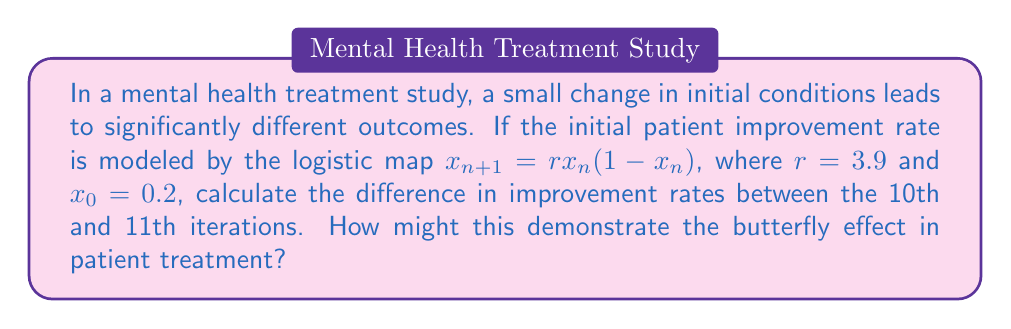Show me your answer to this math problem. To solve this problem, we need to iterate the logistic map for 11 steps and compare the 10th and 11th iterations. Let's break it down:

1) The logistic map is given by: $x_{n+1} = rx_n(1-x_n)$
   Where $r=3.9$ and $x_0=0.2$

2) Let's calculate the first 11 iterations:

   $x_1 = 3.9 * 0.2 * (1-0.2) = 0.624$
   $x_2 = 3.9 * 0.624 * (1-0.624) \approx 0.915406$
   $x_3 = 3.9 * 0.915406 * (1-0.915406) \approx 0.301973$
   $x_4 \approx 0.821623$
   $x_5 \approx 0.570607$
   $x_6 \approx 0.955289$
   $x_7 \approx 0.166594$
   $x_8 \approx 0.541144$
   $x_9 \approx 0.968279$
   $x_{10} \approx 0.119726$
   $x_{11} \approx 0.411235$

3) The difference between the 10th and 11th iterations is:
   $|x_{11} - x_{10}| = |0.411235 - 0.119726| \approx 0.291509$

4) This significant difference after just one more iteration demonstrates the butterfly effect. In the context of patient treatment, it suggests that even small changes in treatment approach or patient response can lead to drastically different outcomes over time.
Answer: $0.291509$ 